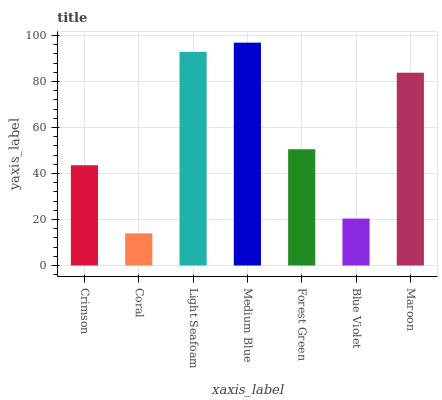Is Coral the minimum?
Answer yes or no. Yes. Is Medium Blue the maximum?
Answer yes or no. Yes. Is Light Seafoam the minimum?
Answer yes or no. No. Is Light Seafoam the maximum?
Answer yes or no. No. Is Light Seafoam greater than Coral?
Answer yes or no. Yes. Is Coral less than Light Seafoam?
Answer yes or no. Yes. Is Coral greater than Light Seafoam?
Answer yes or no. No. Is Light Seafoam less than Coral?
Answer yes or no. No. Is Forest Green the high median?
Answer yes or no. Yes. Is Forest Green the low median?
Answer yes or no. Yes. Is Medium Blue the high median?
Answer yes or no. No. Is Light Seafoam the low median?
Answer yes or no. No. 